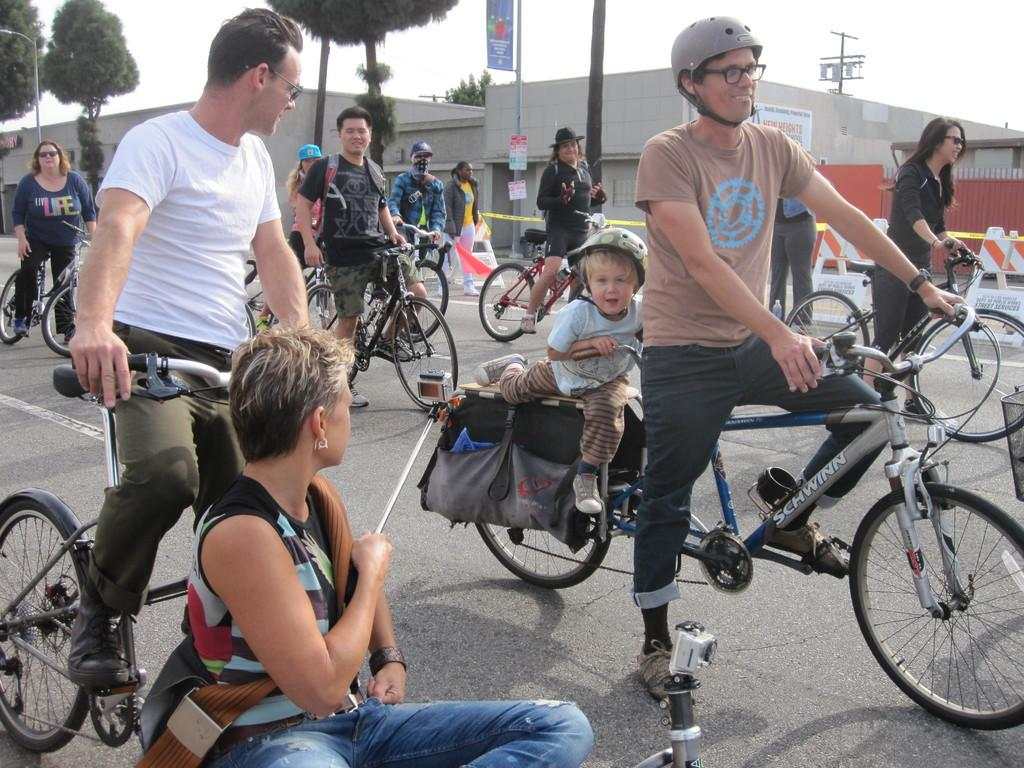What are the people in the image doing? People are riding bicycles on the road. Are any safety precautions being taken by the cyclists? Yes, one person is wearing a helmet. What can be seen in the background of the image? There is a building and trees in the background. What type of calculator is being used by the person riding the bicycle? There is no calculator present in the image; people are riding bicycles on the road. 